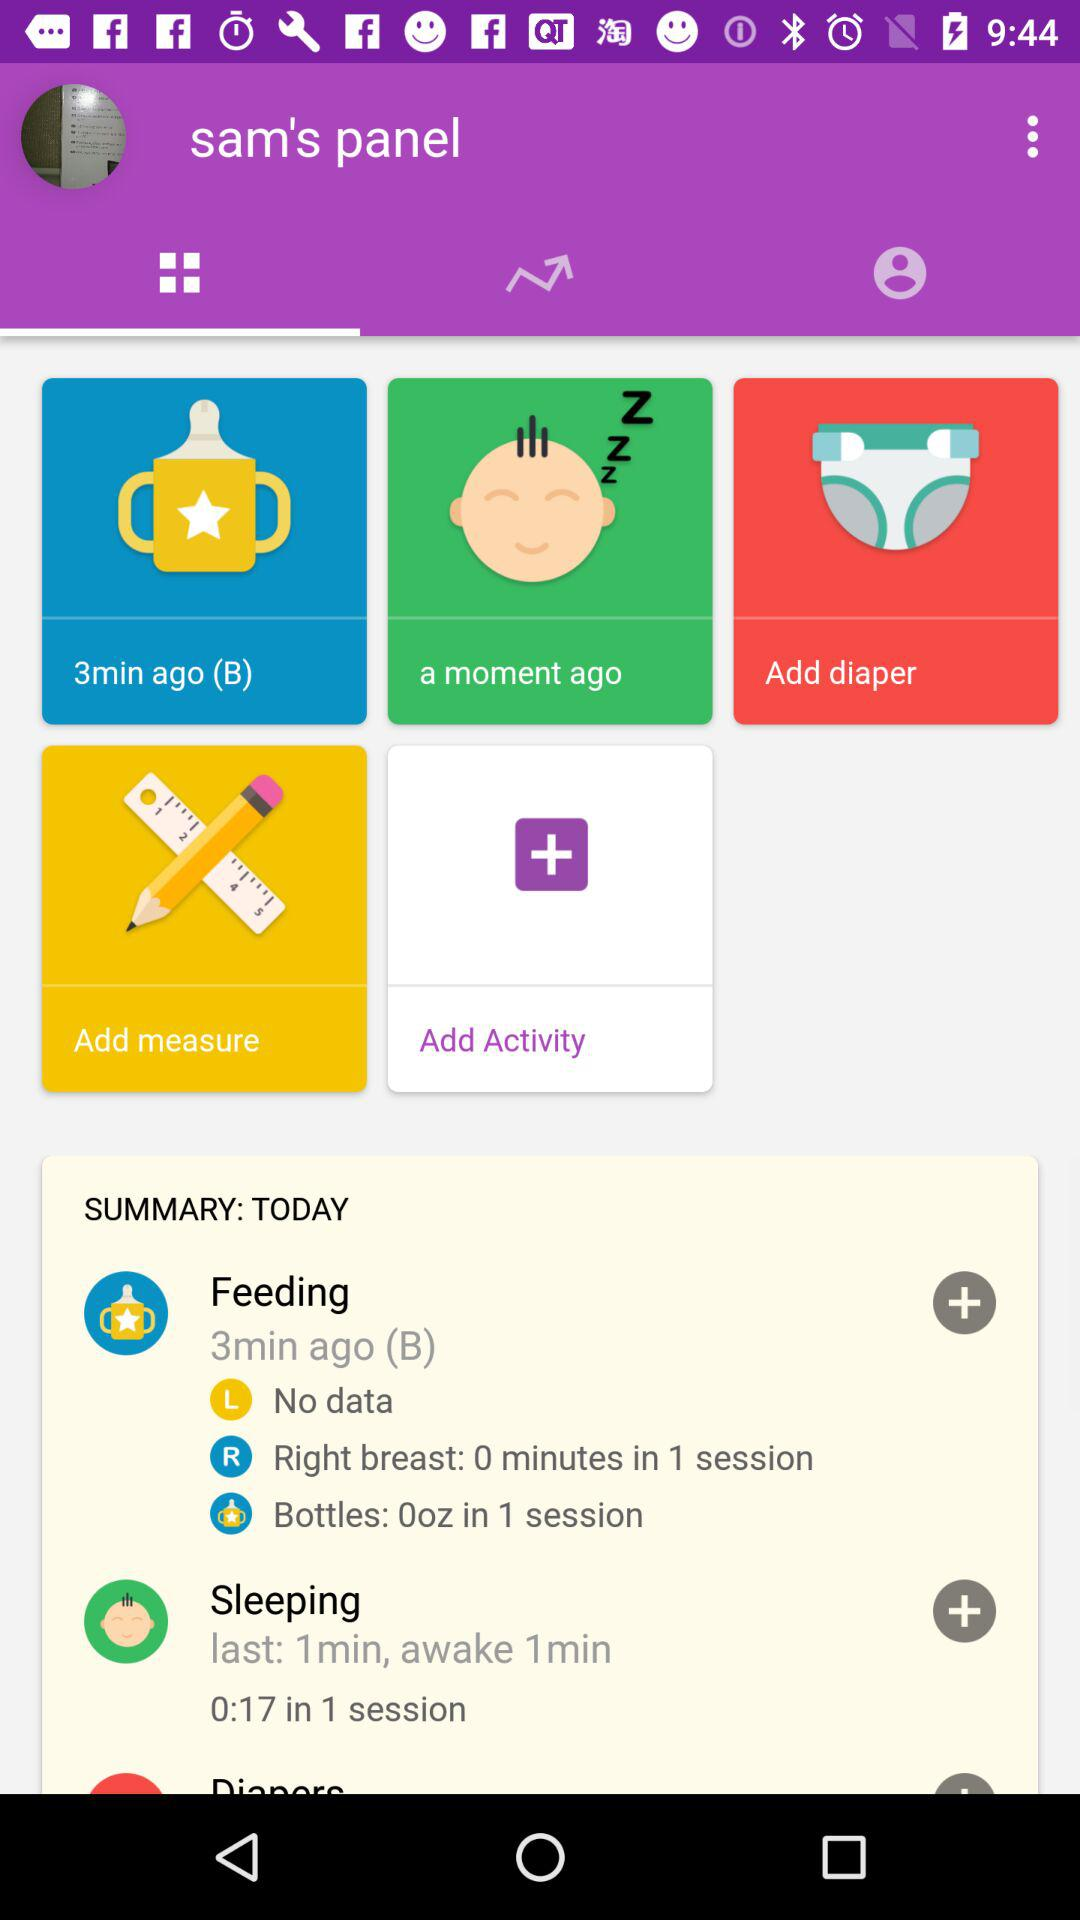Which number session is there?
When the provided information is insufficient, respond with <no answer>. <no answer> 